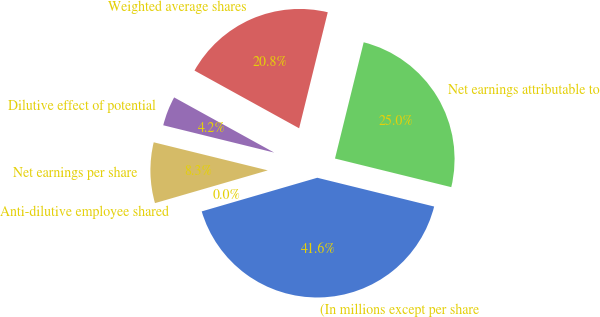Convert chart to OTSL. <chart><loc_0><loc_0><loc_500><loc_500><pie_chart><fcel>(In millions except per share<fcel>Net earnings attributable to<fcel>Weighted average shares<fcel>Dilutive effect of potential<fcel>Net earnings per share<fcel>Anti-dilutive employee shared<nl><fcel>41.65%<fcel>24.99%<fcel>20.83%<fcel>4.18%<fcel>8.34%<fcel>0.01%<nl></chart> 